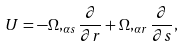Convert formula to latex. <formula><loc_0><loc_0><loc_500><loc_500>U = - \Omega , _ { \alpha s } \frac { \partial } { \partial r } + \Omega , _ { \alpha r } \frac { \partial } { \partial s } ,</formula> 